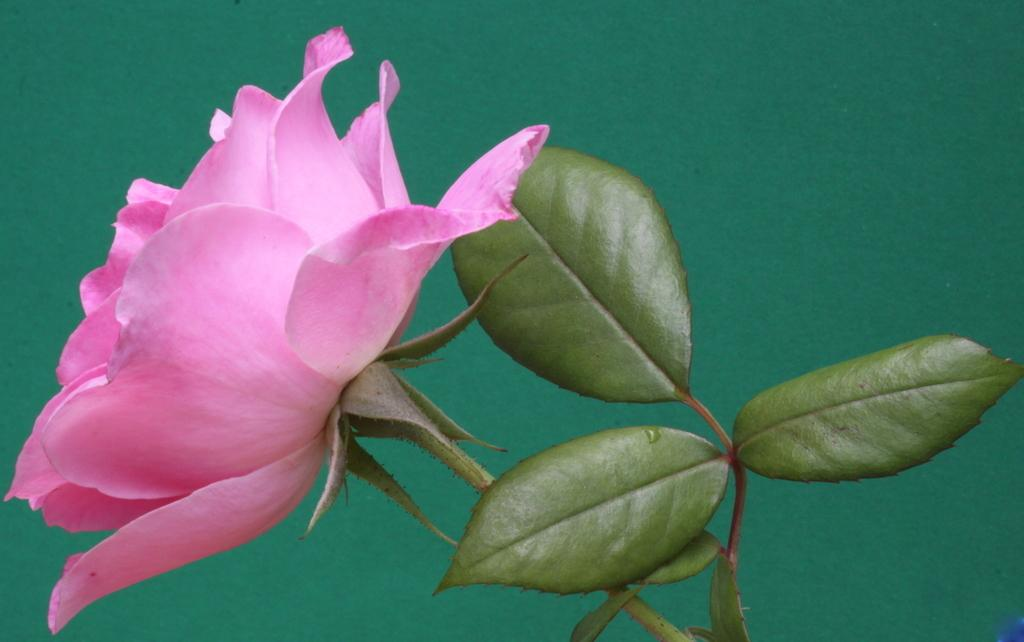What type of flower is present in the image? There is a pink flower in the image. What else can be seen in the image besides the flower? There are leaves in the image. What color is the background of the image? The background of the image is green. What type of force is being applied to the flower in the image? There is no force being applied to the flower in the image; it is stationary. 